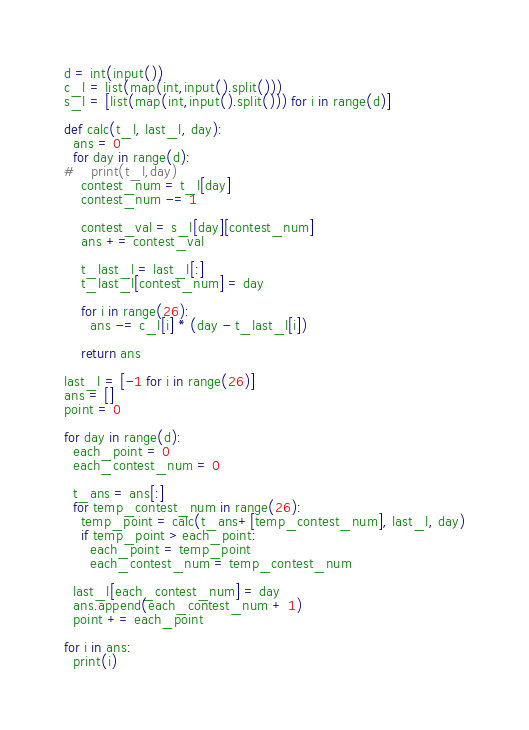<code> <loc_0><loc_0><loc_500><loc_500><_Python_>d = int(input())
c_l = list(map(int,input().split()))
s_l = [list(map(int,input().split())) for i in range(d)]

def calc(t_l, last_l, day):
  ans = 0
  for day in range(d):
#    print(t_l,day)
    contest_num = t_l[day]
    contest_num -= 1

    contest_val = s_l[day][contest_num]
    ans += contest_val

    t_last_l = last_l[:]
    t_last_l[contest_num] = day

    for i in range(26):
      ans -= c_l[i] * (day - t_last_l[i])

    return ans

last_l = [-1 for i in range(26)]
ans = []
point = 0

for day in range(d):
  each_point = 0
  each_contest_num = 0

  t_ans = ans[:]
  for temp_contest_num in range(26):
    temp_point = calc(t_ans+[temp_contest_num], last_l, day)
    if temp_point > each_point:
      each_point = temp_point
      each_contest_num = temp_contest_num

  last_l[each_contest_num] = day
  ans.append(each_contest_num + 1)
  point += each_point

for i in ans:
  print(i)</code> 